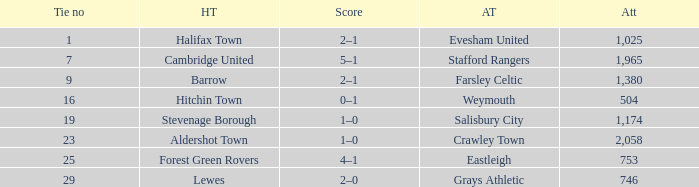What is the highest attendance for games with stevenage borough at home? 1174.0. Give me the full table as a dictionary. {'header': ['Tie no', 'HT', 'Score', 'AT', 'Att'], 'rows': [['1', 'Halifax Town', '2–1', 'Evesham United', '1,025'], ['7', 'Cambridge United', '5–1', 'Stafford Rangers', '1,965'], ['9', 'Barrow', '2–1', 'Farsley Celtic', '1,380'], ['16', 'Hitchin Town', '0–1', 'Weymouth', '504'], ['19', 'Stevenage Borough', '1–0', 'Salisbury City', '1,174'], ['23', 'Aldershot Town', '1–0', 'Crawley Town', '2,058'], ['25', 'Forest Green Rovers', '4–1', 'Eastleigh', '753'], ['29', 'Lewes', '2–0', 'Grays Athletic', '746']]} 